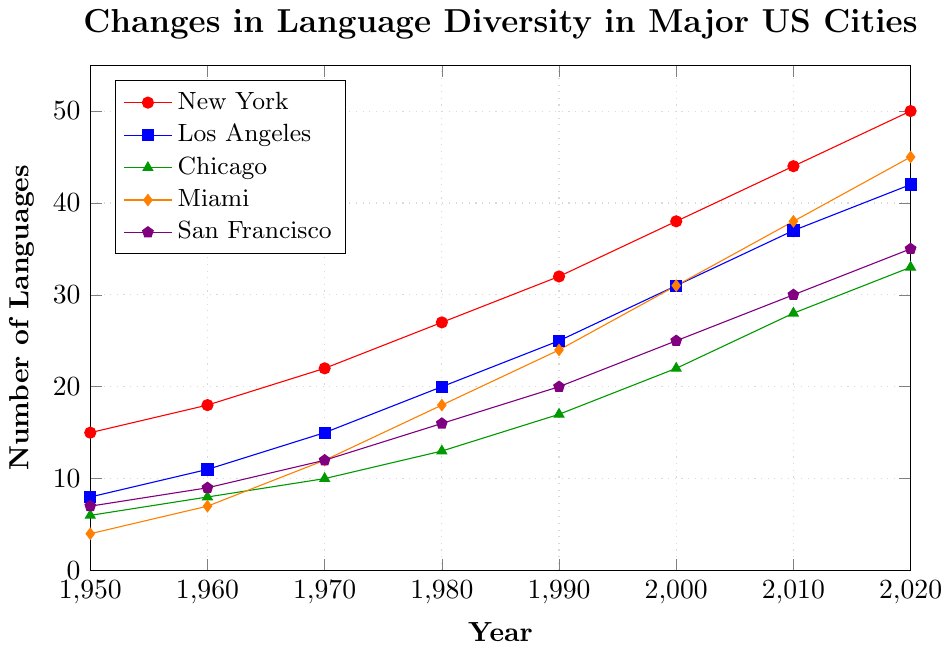Which city had the highest number of languages spoken in 2020? The figure shows the number of languages spoken in different cities over the years. In 2020, New York had the highest number, marked by the topmost line ending at 50.
Answer: New York How many more languages were spoken in Los Angeles in 1980 compared to 1970? In 1970, Los Angeles had 15 languages spoken, and in 1980, there were 20 languages spoken. The difference is 20 - 15.
Answer: 5 What was the average number of languages spoken in San Francisco in the years 1960, 1970, and 1980? Summing up the number of languages in San Francisco for 1960 (9), 1970 (12), and 1980 (16), we get 9 + 12 + 16 = 37. The average is 37 / 3.
Answer: 12.33 In which decade did Miami see the largest increase in the number of languages spoken? The largest increase for Miami can be observed by comparing the increase between each decade. Between 1970 and 1980, it increased from 12 to 18, which equals 6. Between 1980 and 1990, it increased from 18 to 24, which equals 6. Between 1990 and 2000, it increased from 24 to 31, which equals 7. Between 2000 and 2010, it increased from 31 to 38, which equals 7. Between 2010 and 2020, it increased from 38 to 45, which equals 7. The largest increase is 7, first observed in the 1990s.
Answer: 1990s Compare the language diversity in New York and Chicago in 2000. Which city had more languages spoken, and by how much? In 2000, New York had 38 languages spoken while Chicago had 22. The difference is 38 - 22.
Answer: New York by 16 Which city saw a consistent increase in language diversity without any decline from 1950 to 2020? Each line in the figure represents a city's language diversity over the years. A consistent increase means there are no dips or declines. All five cities show consistent increases: New York, Los Angeles, Chicago, Miami, and San Francisco.
Answer: All cities What is the combined total of languages spoken in all five cities in 1990? Summing up the languages spoken in each city in 1990: New York (32), Los Angeles (25), Chicago (17), Miami (24), and San Francisco (20). Total is 32 + 25 + 17 + 24 + 20.
Answer: 118 How many decades did it take for San Francisco to reach 35 languages spoken, starting from 1950? The figure shows that San Francisco had 35 languages spoken in 2020. It started from 1950 with 7 languages. Counting the decades from 1950 to 2020: 1950-1960, 1960-1970, 1970-1980, 1980-1990, 1990-2000, 2000-2010, 2010-2020.
Answer: 7 decades 